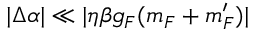<formula> <loc_0><loc_0><loc_500><loc_500>| \Delta \alpha | \ll | \eta \beta g _ { F } ( m _ { F } + m _ { F } ^ { \prime } ) |</formula> 